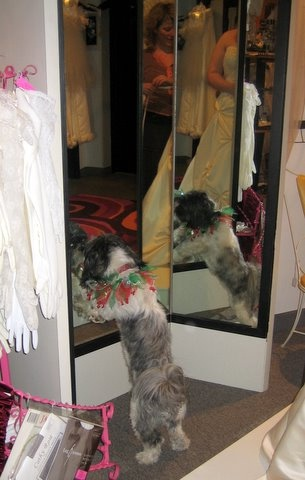Describe the objects in this image and their specific colors. I can see dog in gray, black, and darkgray tones, dog in gray and black tones, people in gray and olive tones, people in gray, black, maroon, and brown tones, and chair in gray, brown, maroon, and black tones in this image. 